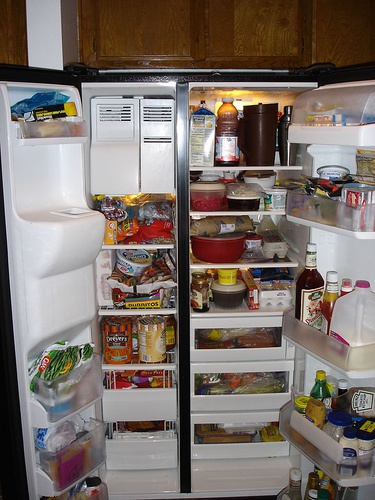Describe the objects in this image and their specific colors. I can see refrigerator in darkgray, black, lightgray, and gray tones, bottle in black, darkgray, lightgray, and purple tones, bottle in black, darkgray, lightgray, and gray tones, bowl in black, maroon, and brown tones, and bottle in black, lightgray, maroon, and darkgray tones in this image. 